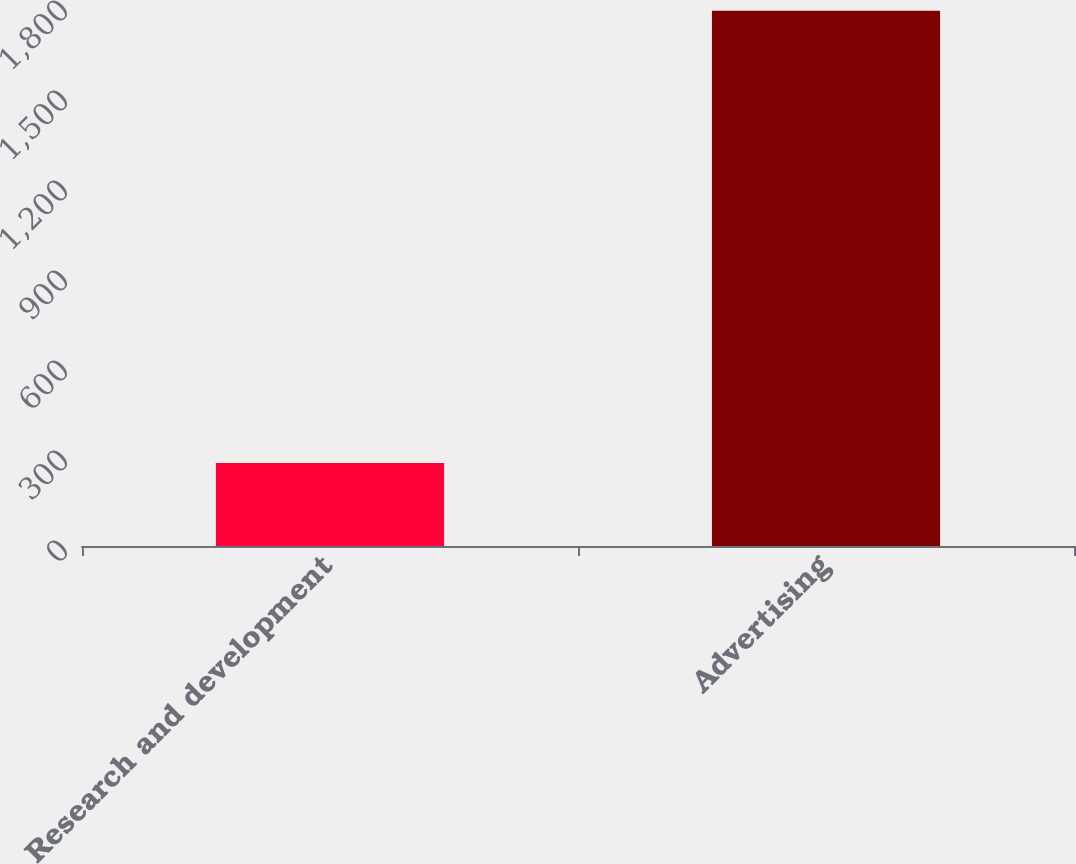<chart> <loc_0><loc_0><loc_500><loc_500><bar_chart><fcel>Research and development<fcel>Advertising<nl><fcel>277<fcel>1784<nl></chart> 